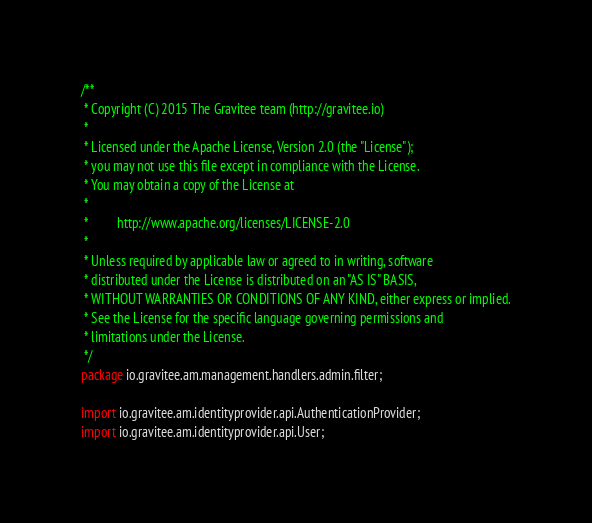<code> <loc_0><loc_0><loc_500><loc_500><_Java_>/**
 * Copyright (C) 2015 The Gravitee team (http://gravitee.io)
 *
 * Licensed under the Apache License, Version 2.0 (the "License");
 * you may not use this file except in compliance with the License.
 * You may obtain a copy of the License at
 *
 *         http://www.apache.org/licenses/LICENSE-2.0
 *
 * Unless required by applicable law or agreed to in writing, software
 * distributed under the License is distributed on an "AS IS" BASIS,
 * WITHOUT WARRANTIES OR CONDITIONS OF ANY KIND, either express or implied.
 * See the License for the specific language governing permissions and
 * limitations under the License.
 */
package io.gravitee.am.management.handlers.admin.filter;

import io.gravitee.am.identityprovider.api.AuthenticationProvider;
import io.gravitee.am.identityprovider.api.User;</code> 